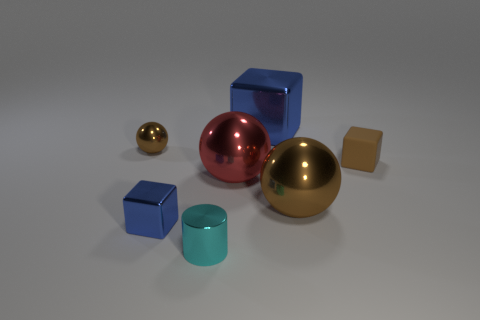What is the size of the other cube that is the same color as the big metallic block?
Provide a short and direct response. Small. Is the size of the shiny block in front of the small rubber thing the same as the metallic cube on the right side of the large red sphere?
Ensure brevity in your answer.  No. What is the size of the shiny block to the right of the tiny cyan metal thing?
Make the answer very short. Large. Are there any big blocks of the same color as the tiny rubber object?
Your answer should be very brief. No. There is a brown metallic thing on the left side of the big cube; is there a tiny cylinder to the left of it?
Give a very brief answer. No. There is a brown rubber block; is it the same size as the block left of the large red object?
Offer a very short reply. Yes. There is a small thing that is on the left side of the blue thing that is in front of the small matte block; is there a small metal thing in front of it?
Keep it short and to the point. Yes. What is the sphere on the left side of the shiny cylinder made of?
Your answer should be compact. Metal. Is the size of the cylinder the same as the brown matte thing?
Give a very brief answer. Yes. There is a block that is both on the left side of the brown rubber object and in front of the tiny metallic ball; what is its color?
Offer a terse response. Blue. 